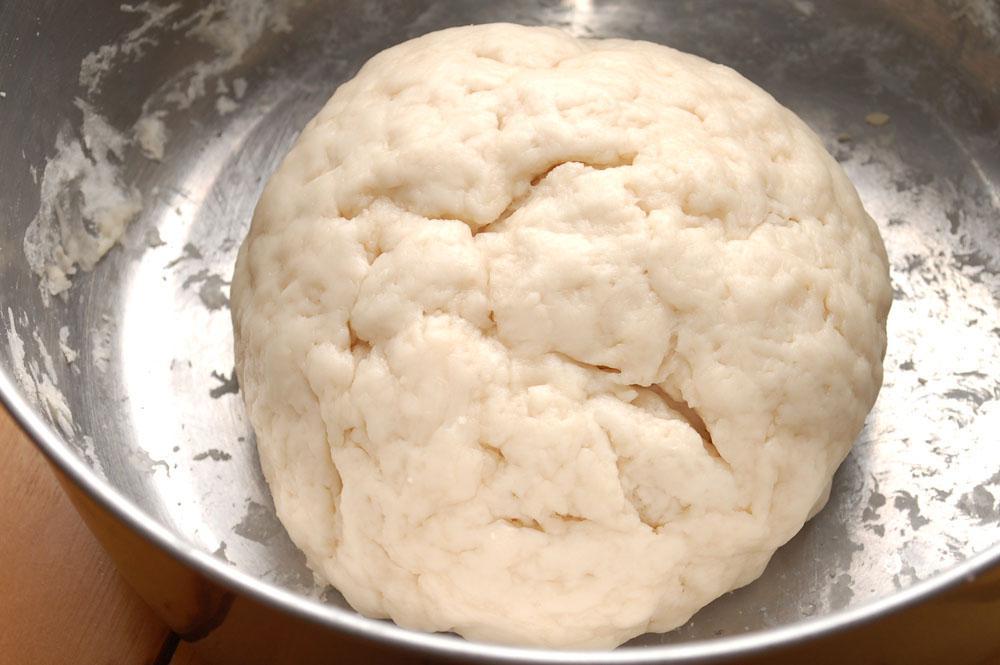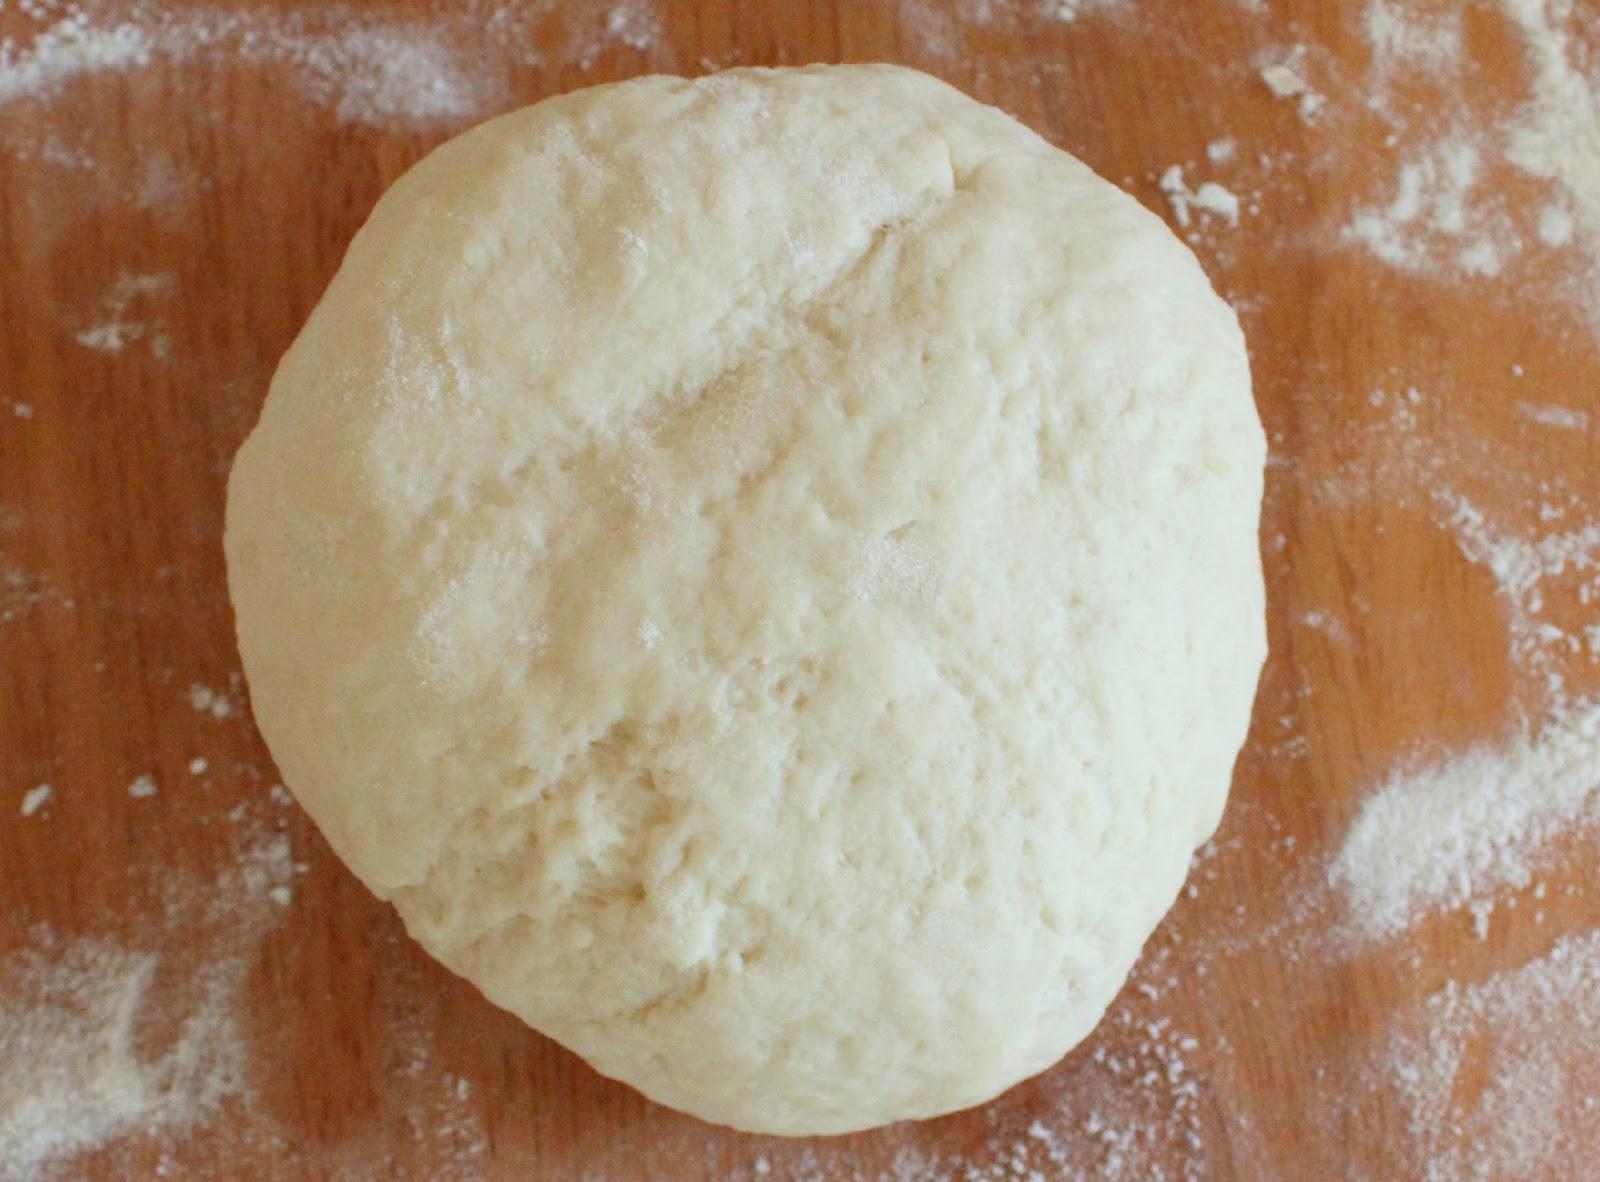The first image is the image on the left, the second image is the image on the right. Analyze the images presented: Is the assertion "Dough is rolled into a round ball in the image on the right." valid? Answer yes or no. Yes. The first image is the image on the left, the second image is the image on the right. For the images displayed, is the sentence "A person has their hands in the dough in one picture but not the other." factually correct? Answer yes or no. No. 